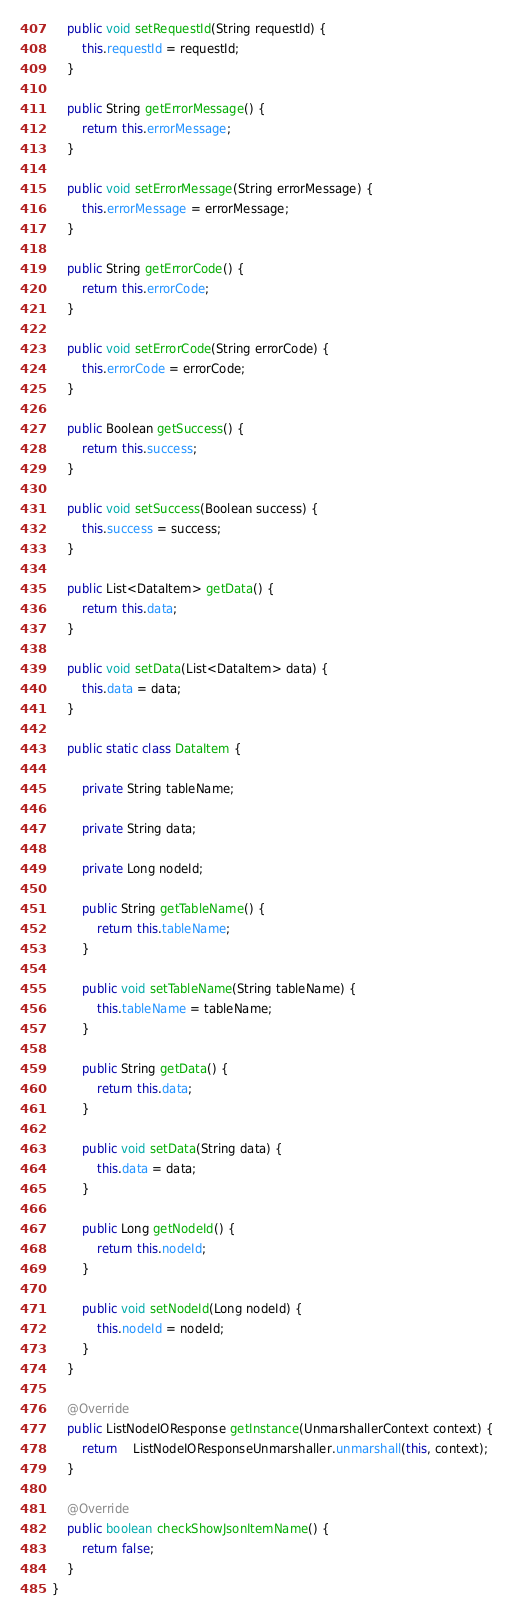<code> <loc_0><loc_0><loc_500><loc_500><_Java_>
	public void setRequestId(String requestId) {
		this.requestId = requestId;
	}

	public String getErrorMessage() {
		return this.errorMessage;
	}

	public void setErrorMessage(String errorMessage) {
		this.errorMessage = errorMessage;
	}

	public String getErrorCode() {
		return this.errorCode;
	}

	public void setErrorCode(String errorCode) {
		this.errorCode = errorCode;
	}

	public Boolean getSuccess() {
		return this.success;
	}

	public void setSuccess(Boolean success) {
		this.success = success;
	}

	public List<DataItem> getData() {
		return this.data;
	}

	public void setData(List<DataItem> data) {
		this.data = data;
	}

	public static class DataItem {

		private String tableName;

		private String data;

		private Long nodeId;

		public String getTableName() {
			return this.tableName;
		}

		public void setTableName(String tableName) {
			this.tableName = tableName;
		}

		public String getData() {
			return this.data;
		}

		public void setData(String data) {
			this.data = data;
		}

		public Long getNodeId() {
			return this.nodeId;
		}

		public void setNodeId(Long nodeId) {
			this.nodeId = nodeId;
		}
	}

	@Override
	public ListNodeIOResponse getInstance(UnmarshallerContext context) {
		return	ListNodeIOResponseUnmarshaller.unmarshall(this, context);
	}

	@Override
	public boolean checkShowJsonItemName() {
		return false;
	}
}
</code> 